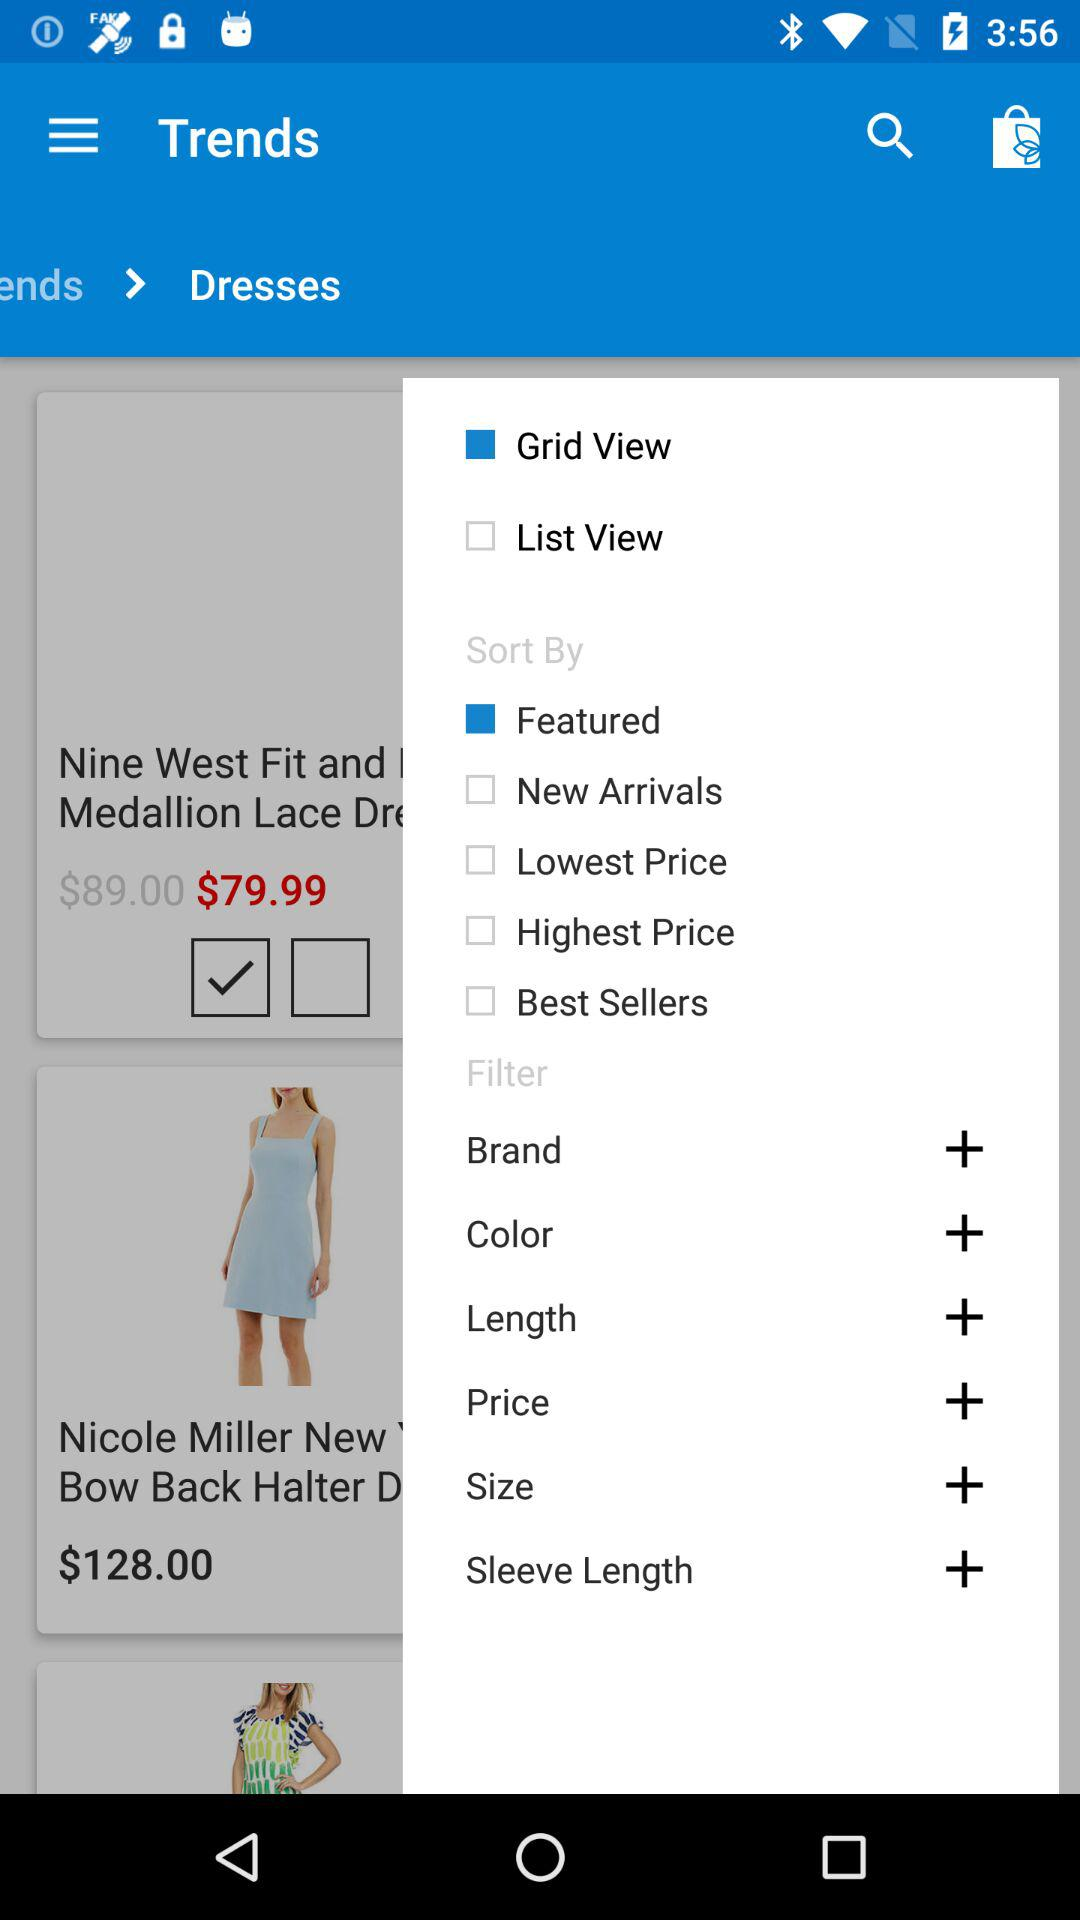Which option is marked for the view? The option marked for the view is "Grid View". 